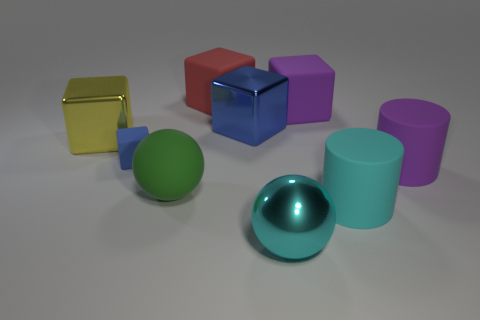How many blue cubes must be subtracted to get 1 blue cubes? 1 Subtract all large purple rubber cubes. How many cubes are left? 4 Subtract 1 cylinders. How many cylinders are left? 1 Subtract all brown cylinders. How many blue blocks are left? 2 Subtract all purple cubes. How many cubes are left? 4 Add 1 big yellow shiny cubes. How many objects exist? 10 Subtract all cylinders. How many objects are left? 7 Subtract all blue blocks. Subtract all purple cylinders. How many blocks are left? 3 Subtract all big yellow blocks. Subtract all yellow objects. How many objects are left? 7 Add 7 big cyan matte cylinders. How many big cyan matte cylinders are left? 8 